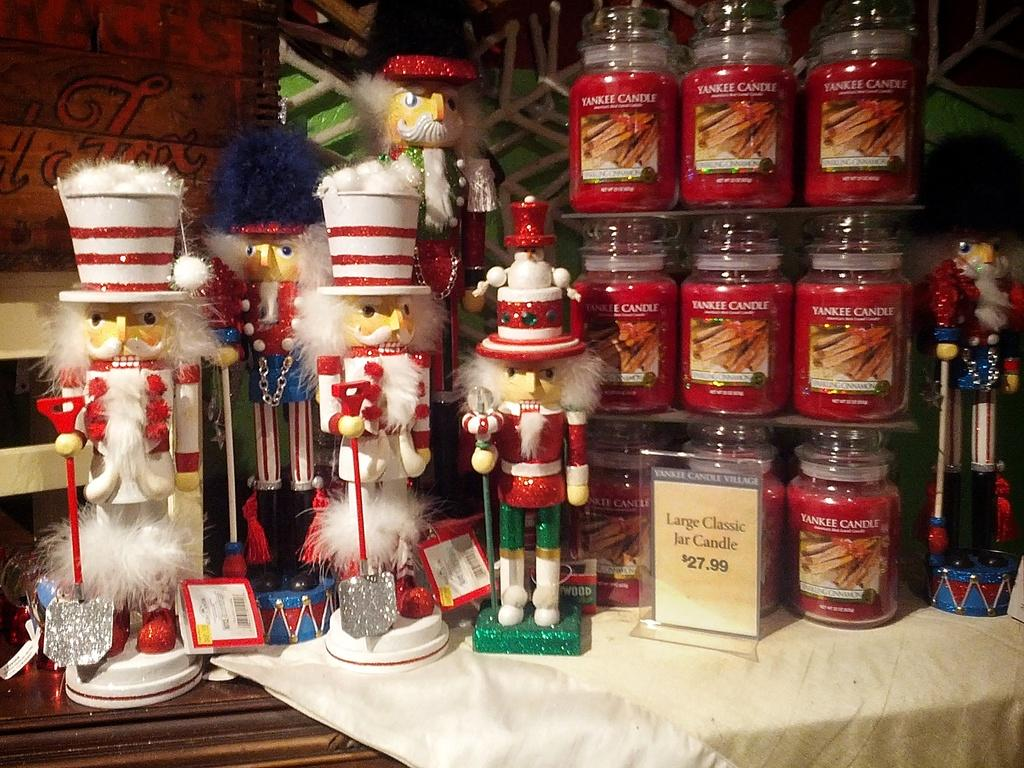<image>
Offer a succinct explanation of the picture presented. a few nutcrackers next to Yankee Candle Company candles 